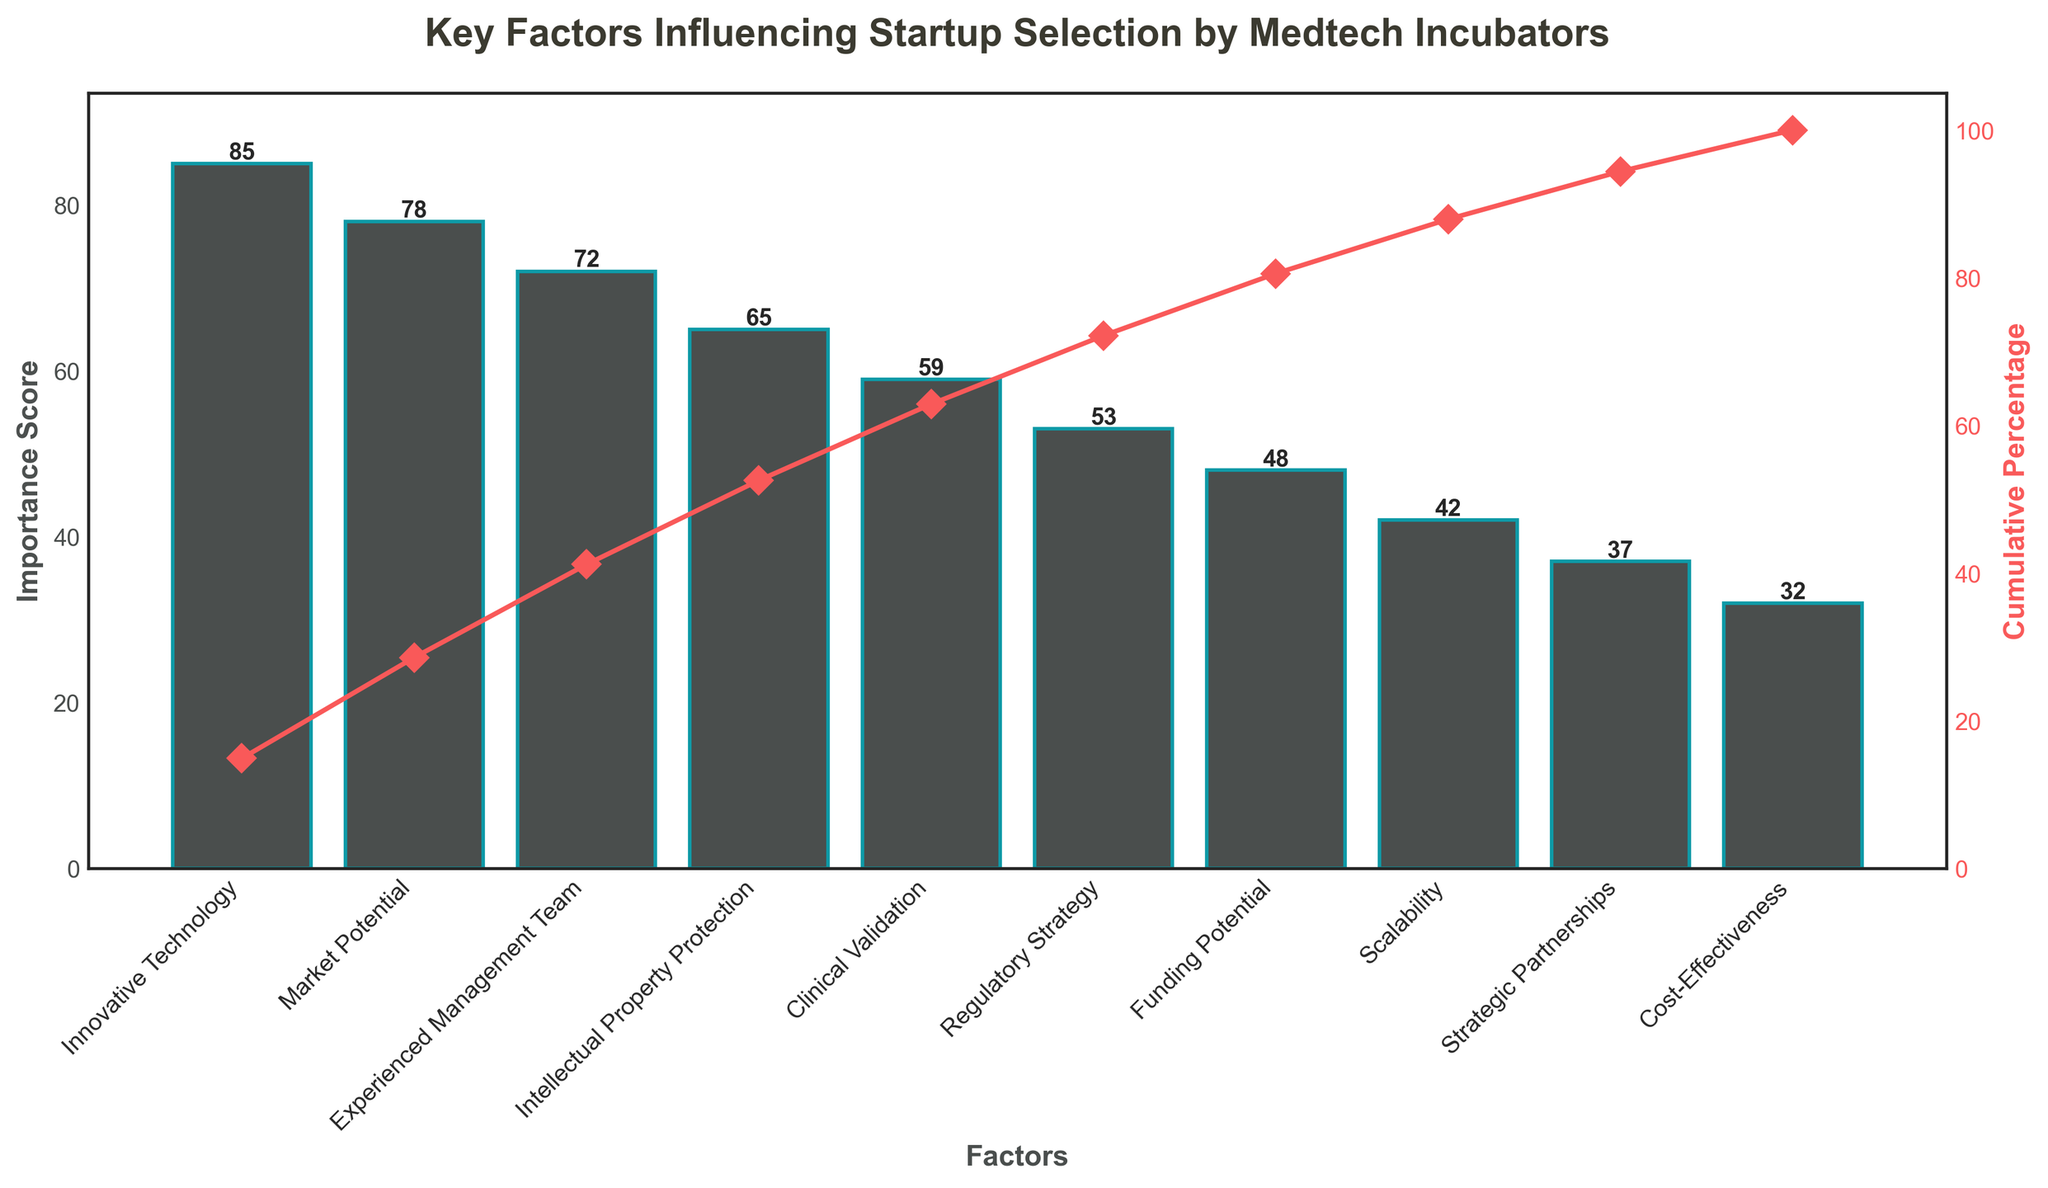What is the title of the figure? The title is typically located at the top of the figure, displaying a brief description of what the chart represents. In this case, the title is prominently mentioned at the top.
Answer: Key Factors Influencing Startup Selection by Medtech Incubators How many factors are listed in the figure? The x-axis usually lists all the factors being considered. By counting the bars on the x-axis, one can determine the number of factors.
Answer: 10 Which factor has the highest importance score? By looking at the height of the bars, the tallest bar represents the factor with the highest importance score.
Answer: Innovative Technology What is the cumulative percentage after including the top three factors? To find the cumulative percentage, add the scores of the top three factors and then look at the cumulative percentage line on the y2-axis. The innovative technology, market potential, and experienced management team sum to 85 + 78 + 72 = 235. The cumulative percentage at that point is shown on the line graph.
Answer: Approximately 71% What is the difference in importance score between 'Innovative Technology' and 'Clinical Validation'? Subtract the score of Clinical Validation from the score of Innovative Technology (85 - 59).
Answer: 26 Is the importance score of 'Regulatory Strategy' greater than or less than 'Funding Potential'? Compare the height of the bars for Regulatory Strategy and Funding Potential directly on the chart.
Answer: Greater than Which two factors have the closest importance scores and what are they? Look at the bars that are closest in height to find the two factors with the smallest difference in their importance scores.
Answer: Clinical Validation and Regulatory Strategy What percentage of importance is covered by the first five factors? Sum the importance scores of the first five bars and then express that sum as a percentage of the total sum of all importance scores. The scores sum to 85 + 78 + 72 + 65 + 59 = 359. Total sum is 571. So the percentage = (359 / 571) * 100.
Answer: Approximately 62.9% Between 'Scalability' and 'Cost-Effectiveness,' which factor contributes more to the cumulative percentage? Compare the importance scores to see which one is higher, as the higher importance score will contribute more to the cumulative percentage.
Answer: Scalability What factor sees the greatest incremental change in cumulative percentage between itself and the next highest factor? Look at the steepest segment of the cumulative percentage line to identify where the greatest jump occurs, indicating the largest incremental change in the cumulative percentage.
Answer: Innovative Technology 